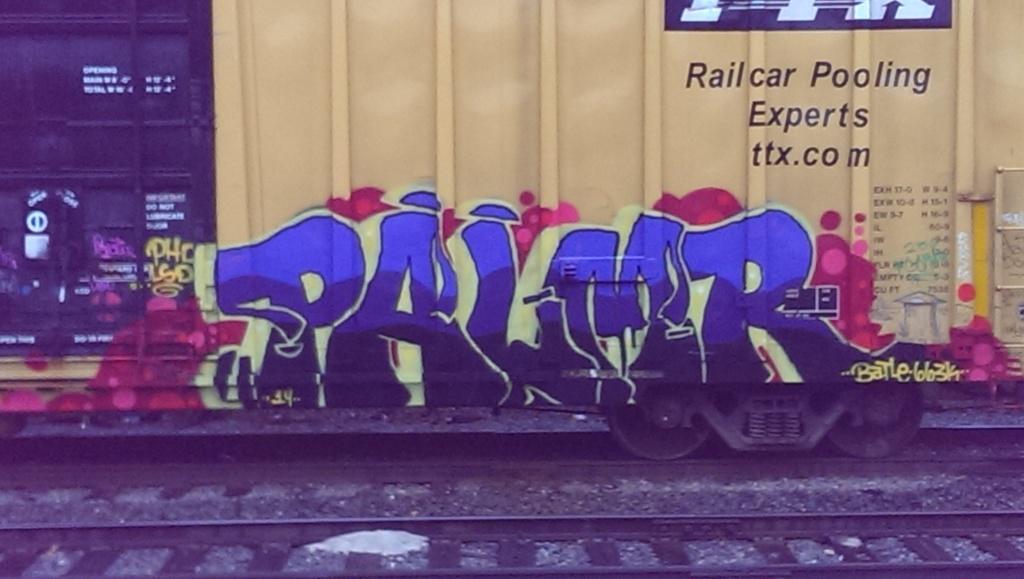Who did the tag?
Ensure brevity in your answer.  Palmr. 